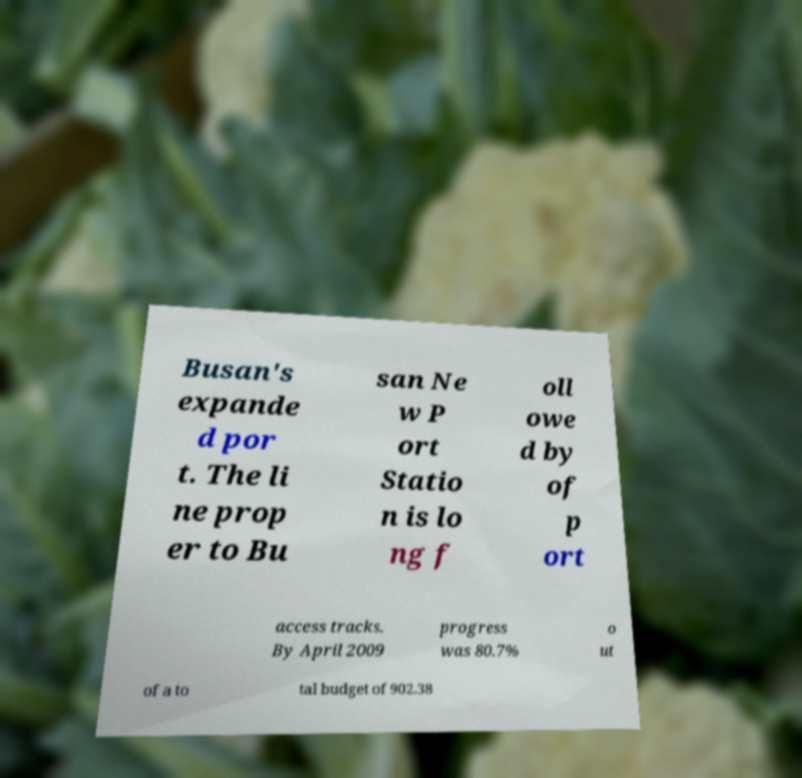Please identify and transcribe the text found in this image. Busan's expande d por t. The li ne prop er to Bu san Ne w P ort Statio n is lo ng f oll owe d by of p ort access tracks. By April 2009 progress was 80.7% o ut of a to tal budget of 902.38 